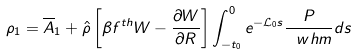Convert formula to latex. <formula><loc_0><loc_0><loc_500><loc_500>\rho _ { 1 } = \overline { A } _ { 1 } + \hat { \rho } \left [ \beta f ^ { t h } W - \frac { \partial W } { \partial R } \right ] \int _ { - t _ { 0 } } ^ { 0 } e ^ { - \mathcal { L } _ { 0 } s } \frac { P } { \ w h { m } } d s</formula> 